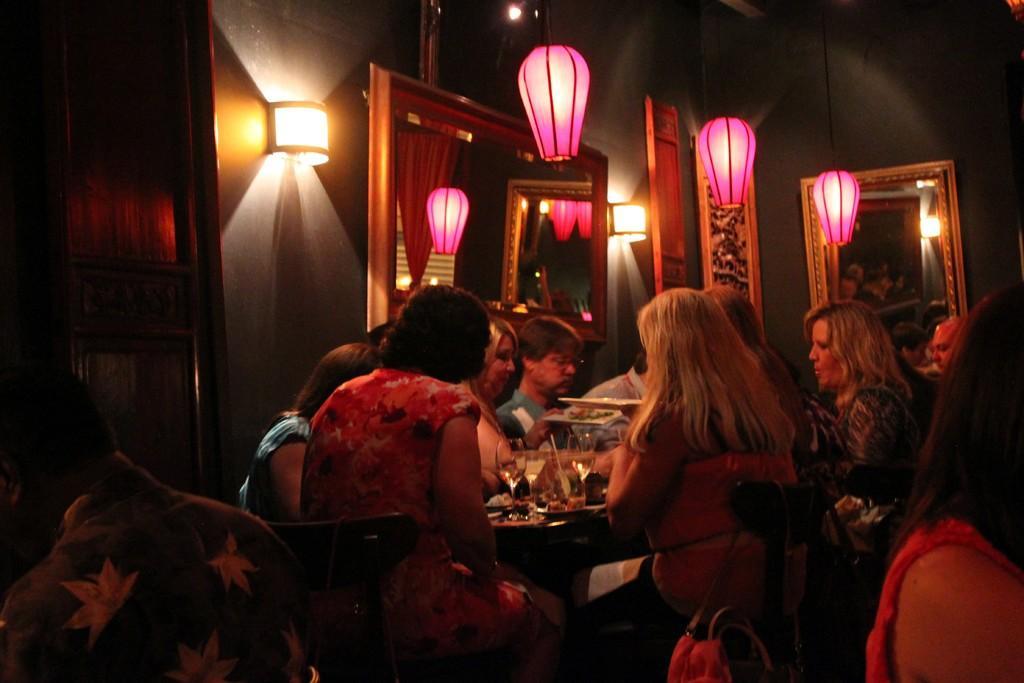How would you summarize this image in a sentence or two? In this image there are few people seated on chairs and having dinner on the dining table, there are plates and glasses on the table, behind them there are Mirrors and lamps on the walls. 